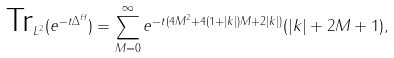Convert formula to latex. <formula><loc_0><loc_0><loc_500><loc_500>\text {Tr} _ { L ^ { 2 } } ( e ^ { - t \Delta ^ { H } } ) = \sum _ { M = 0 } ^ { \infty } e ^ { - t ( 4 M ^ { 2 } + 4 ( 1 + | k | ) M + 2 | k | ) } ( | k | + 2 M + 1 ) ,</formula> 